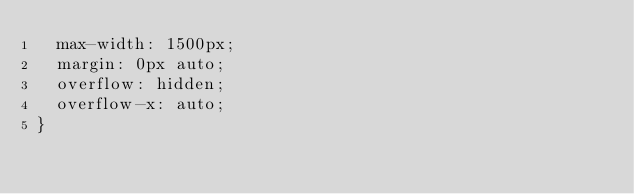Convert code to text. <code><loc_0><loc_0><loc_500><loc_500><_CSS_>  max-width: 1500px;
  margin: 0px auto;
  overflow: hidden;
  overflow-x: auto;
}</code> 